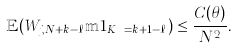Convert formula to latex. <formula><loc_0><loc_0><loc_500><loc_500>\mathbb { E } ( W _ { j , N + k - \ell } \mathbb { m } { 1 } _ { K _ { N } = k + 1 - \ell } ) \leq \frac { C ( \theta ) } { N ^ { 2 } } .</formula> 